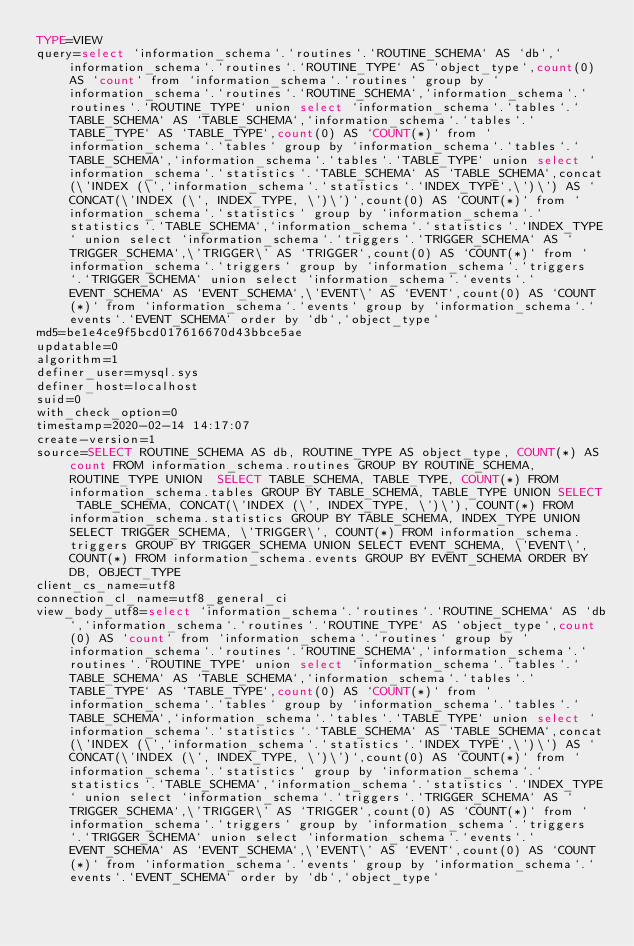Convert code to text. <code><loc_0><loc_0><loc_500><loc_500><_VisualBasic_>TYPE=VIEW
query=select `information_schema`.`routines`.`ROUTINE_SCHEMA` AS `db`,`information_schema`.`routines`.`ROUTINE_TYPE` AS `object_type`,count(0) AS `count` from `information_schema`.`routines` group by `information_schema`.`routines`.`ROUTINE_SCHEMA`,`information_schema`.`routines`.`ROUTINE_TYPE` union select `information_schema`.`tables`.`TABLE_SCHEMA` AS `TABLE_SCHEMA`,`information_schema`.`tables`.`TABLE_TYPE` AS `TABLE_TYPE`,count(0) AS `COUNT(*)` from `information_schema`.`tables` group by `information_schema`.`tables`.`TABLE_SCHEMA`,`information_schema`.`tables`.`TABLE_TYPE` union select `information_schema`.`statistics`.`TABLE_SCHEMA` AS `TABLE_SCHEMA`,concat(\'INDEX (\',`information_schema`.`statistics`.`INDEX_TYPE`,\')\') AS `CONCAT(\'INDEX (\', INDEX_TYPE, \')\')`,count(0) AS `COUNT(*)` from `information_schema`.`statistics` group by `information_schema`.`statistics`.`TABLE_SCHEMA`,`information_schema`.`statistics`.`INDEX_TYPE` union select `information_schema`.`triggers`.`TRIGGER_SCHEMA` AS `TRIGGER_SCHEMA`,\'TRIGGER\' AS `TRIGGER`,count(0) AS `COUNT(*)` from `information_schema`.`triggers` group by `information_schema`.`triggers`.`TRIGGER_SCHEMA` union select `information_schema`.`events`.`EVENT_SCHEMA` AS `EVENT_SCHEMA`,\'EVENT\' AS `EVENT`,count(0) AS `COUNT(*)` from `information_schema`.`events` group by `information_schema`.`events`.`EVENT_SCHEMA` order by `db`,`object_type`
md5=be1e4ce9f5bcd017616670d43bbce5ae
updatable=0
algorithm=1
definer_user=mysql.sys
definer_host=localhost
suid=0
with_check_option=0
timestamp=2020-02-14 14:17:07
create-version=1
source=SELECT ROUTINE_SCHEMA AS db, ROUTINE_TYPE AS object_type, COUNT(*) AS count FROM information_schema.routines GROUP BY ROUTINE_SCHEMA, ROUTINE_TYPE UNION  SELECT TABLE_SCHEMA, TABLE_TYPE, COUNT(*) FROM information_schema.tables GROUP BY TABLE_SCHEMA, TABLE_TYPE UNION SELECT TABLE_SCHEMA, CONCAT(\'INDEX (\', INDEX_TYPE, \')\'), COUNT(*) FROM information_schema.statistics GROUP BY TABLE_SCHEMA, INDEX_TYPE UNION SELECT TRIGGER_SCHEMA, \'TRIGGER\', COUNT(*) FROM information_schema.triggers GROUP BY TRIGGER_SCHEMA UNION SELECT EVENT_SCHEMA, \'EVENT\', COUNT(*) FROM information_schema.events GROUP BY EVENT_SCHEMA ORDER BY DB, OBJECT_TYPE
client_cs_name=utf8
connection_cl_name=utf8_general_ci
view_body_utf8=select `information_schema`.`routines`.`ROUTINE_SCHEMA` AS `db`,`information_schema`.`routines`.`ROUTINE_TYPE` AS `object_type`,count(0) AS `count` from `information_schema`.`routines` group by `information_schema`.`routines`.`ROUTINE_SCHEMA`,`information_schema`.`routines`.`ROUTINE_TYPE` union select `information_schema`.`tables`.`TABLE_SCHEMA` AS `TABLE_SCHEMA`,`information_schema`.`tables`.`TABLE_TYPE` AS `TABLE_TYPE`,count(0) AS `COUNT(*)` from `information_schema`.`tables` group by `information_schema`.`tables`.`TABLE_SCHEMA`,`information_schema`.`tables`.`TABLE_TYPE` union select `information_schema`.`statistics`.`TABLE_SCHEMA` AS `TABLE_SCHEMA`,concat(\'INDEX (\',`information_schema`.`statistics`.`INDEX_TYPE`,\')\') AS `CONCAT(\'INDEX (\', INDEX_TYPE, \')\')`,count(0) AS `COUNT(*)` from `information_schema`.`statistics` group by `information_schema`.`statistics`.`TABLE_SCHEMA`,`information_schema`.`statistics`.`INDEX_TYPE` union select `information_schema`.`triggers`.`TRIGGER_SCHEMA` AS `TRIGGER_SCHEMA`,\'TRIGGER\' AS `TRIGGER`,count(0) AS `COUNT(*)` from `information_schema`.`triggers` group by `information_schema`.`triggers`.`TRIGGER_SCHEMA` union select `information_schema`.`events`.`EVENT_SCHEMA` AS `EVENT_SCHEMA`,\'EVENT\' AS `EVENT`,count(0) AS `COUNT(*)` from `information_schema`.`events` group by `information_schema`.`events`.`EVENT_SCHEMA` order by `db`,`object_type`
</code> 